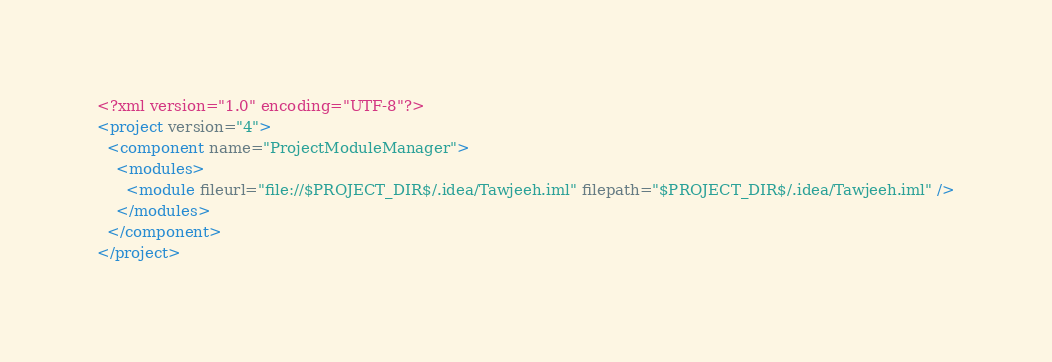<code> <loc_0><loc_0><loc_500><loc_500><_XML_><?xml version="1.0" encoding="UTF-8"?>
<project version="4">
  <component name="ProjectModuleManager">
    <modules>
      <module fileurl="file://$PROJECT_DIR$/.idea/Tawjeeh.iml" filepath="$PROJECT_DIR$/.idea/Tawjeeh.iml" />
    </modules>
  </component>
</project></code> 